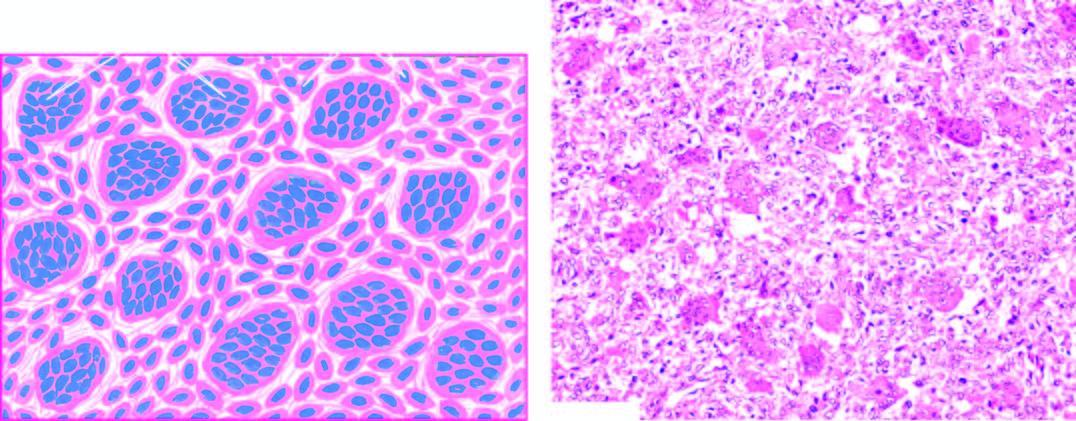what does microscopy reveal?
Answer the question using a single word or phrase. Osteoclast-like multinucleate giant cells which are regularly distributed among the mononuclear stromal cells 